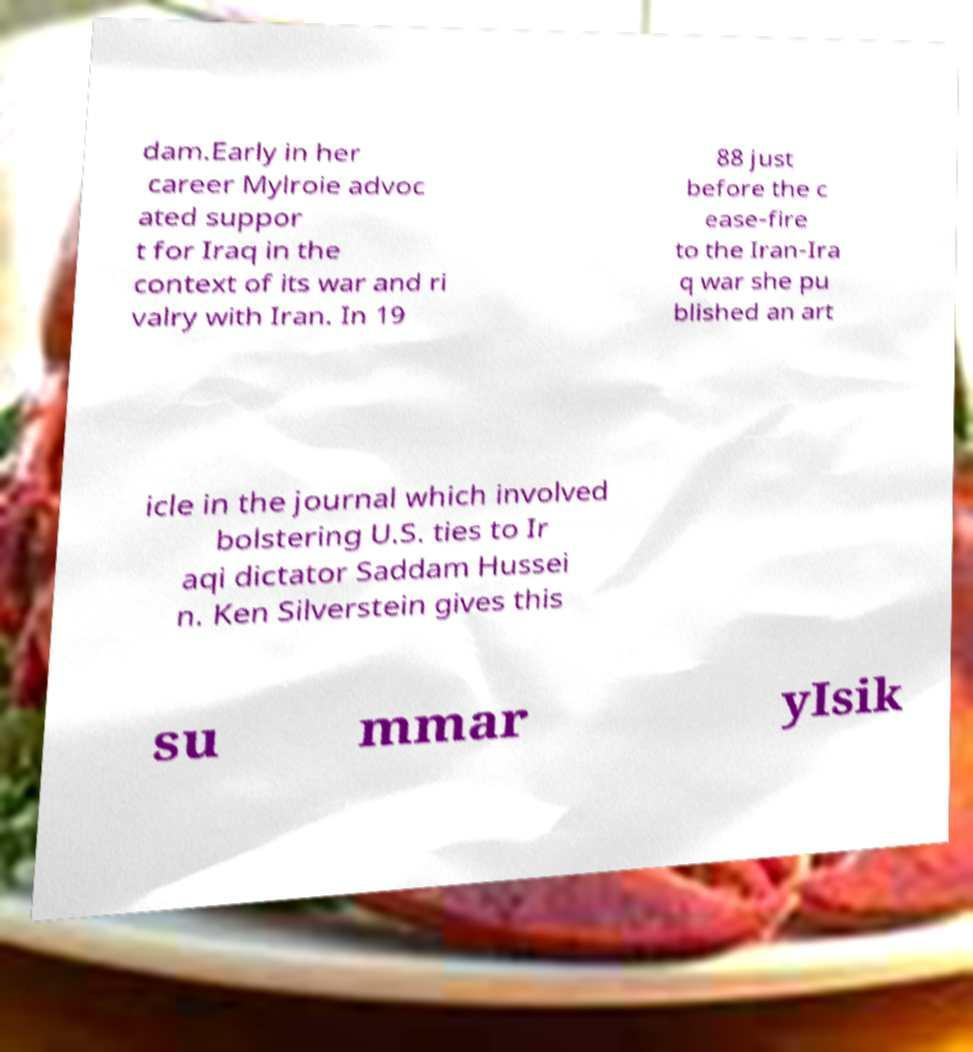There's text embedded in this image that I need extracted. Can you transcribe it verbatim? dam.Early in her career Mylroie advoc ated suppor t for Iraq in the context of its war and ri valry with Iran. In 19 88 just before the c ease-fire to the Iran-Ira q war she pu blished an art icle in the journal which involved bolstering U.S. ties to Ir aqi dictator Saddam Hussei n. Ken Silverstein gives this su mmar yIsik 